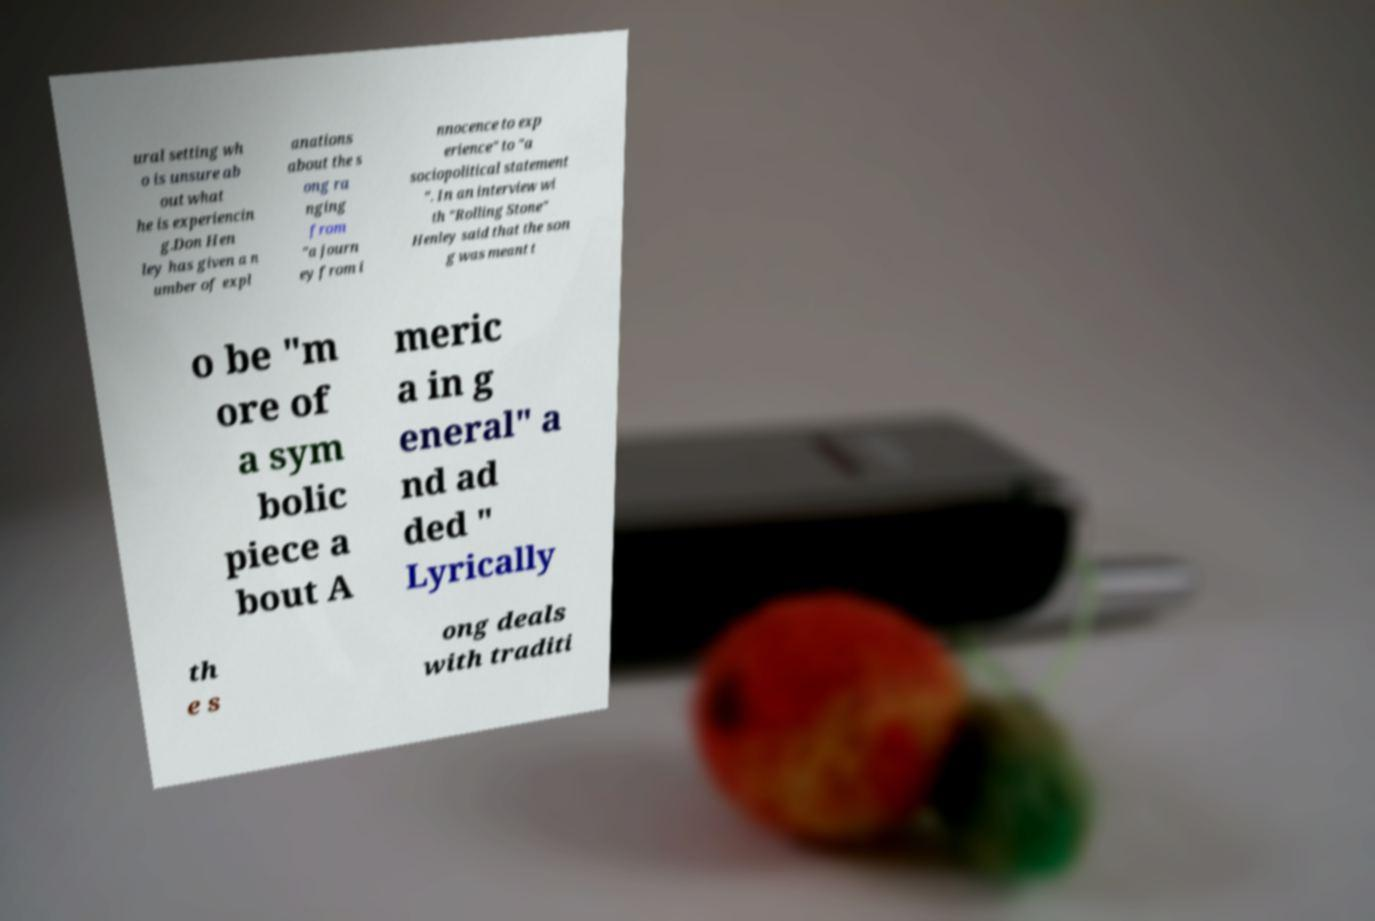What messages or text are displayed in this image? I need them in a readable, typed format. ural setting wh o is unsure ab out what he is experiencin g.Don Hen ley has given a n umber of expl anations about the s ong ra nging from "a journ ey from i nnocence to exp erience" to "a sociopolitical statement ". In an interview wi th "Rolling Stone" Henley said that the son g was meant t o be "m ore of a sym bolic piece a bout A meric a in g eneral" a nd ad ded " Lyrically th e s ong deals with traditi 